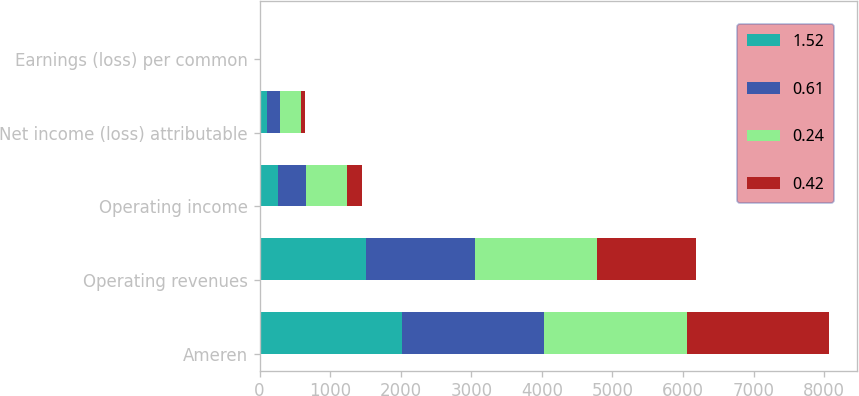Convert chart to OTSL. <chart><loc_0><loc_0><loc_500><loc_500><stacked_bar_chart><ecel><fcel>Ameren<fcel>Operating revenues<fcel>Operating income<fcel>Net income (loss) attributable<fcel>Earnings (loss) per common<nl><fcel>1.52<fcel>2017<fcel>1514<fcel>254<fcel>102<fcel>0.42<nl><fcel>0.61<fcel>2017<fcel>1538<fcel>398<fcel>193<fcel>0.79<nl><fcel>0.24<fcel>2017<fcel>1723<fcel>581<fcel>288<fcel>1.18<nl><fcel>0.42<fcel>2017<fcel>1402<fcel>225<fcel>60<fcel>0.24<nl></chart> 